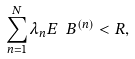Convert formula to latex. <formula><loc_0><loc_0><loc_500><loc_500>\sum _ { n = 1 } ^ { N } \lambda _ { n } E _ { \ } B ^ { ( n ) } < R ,</formula> 